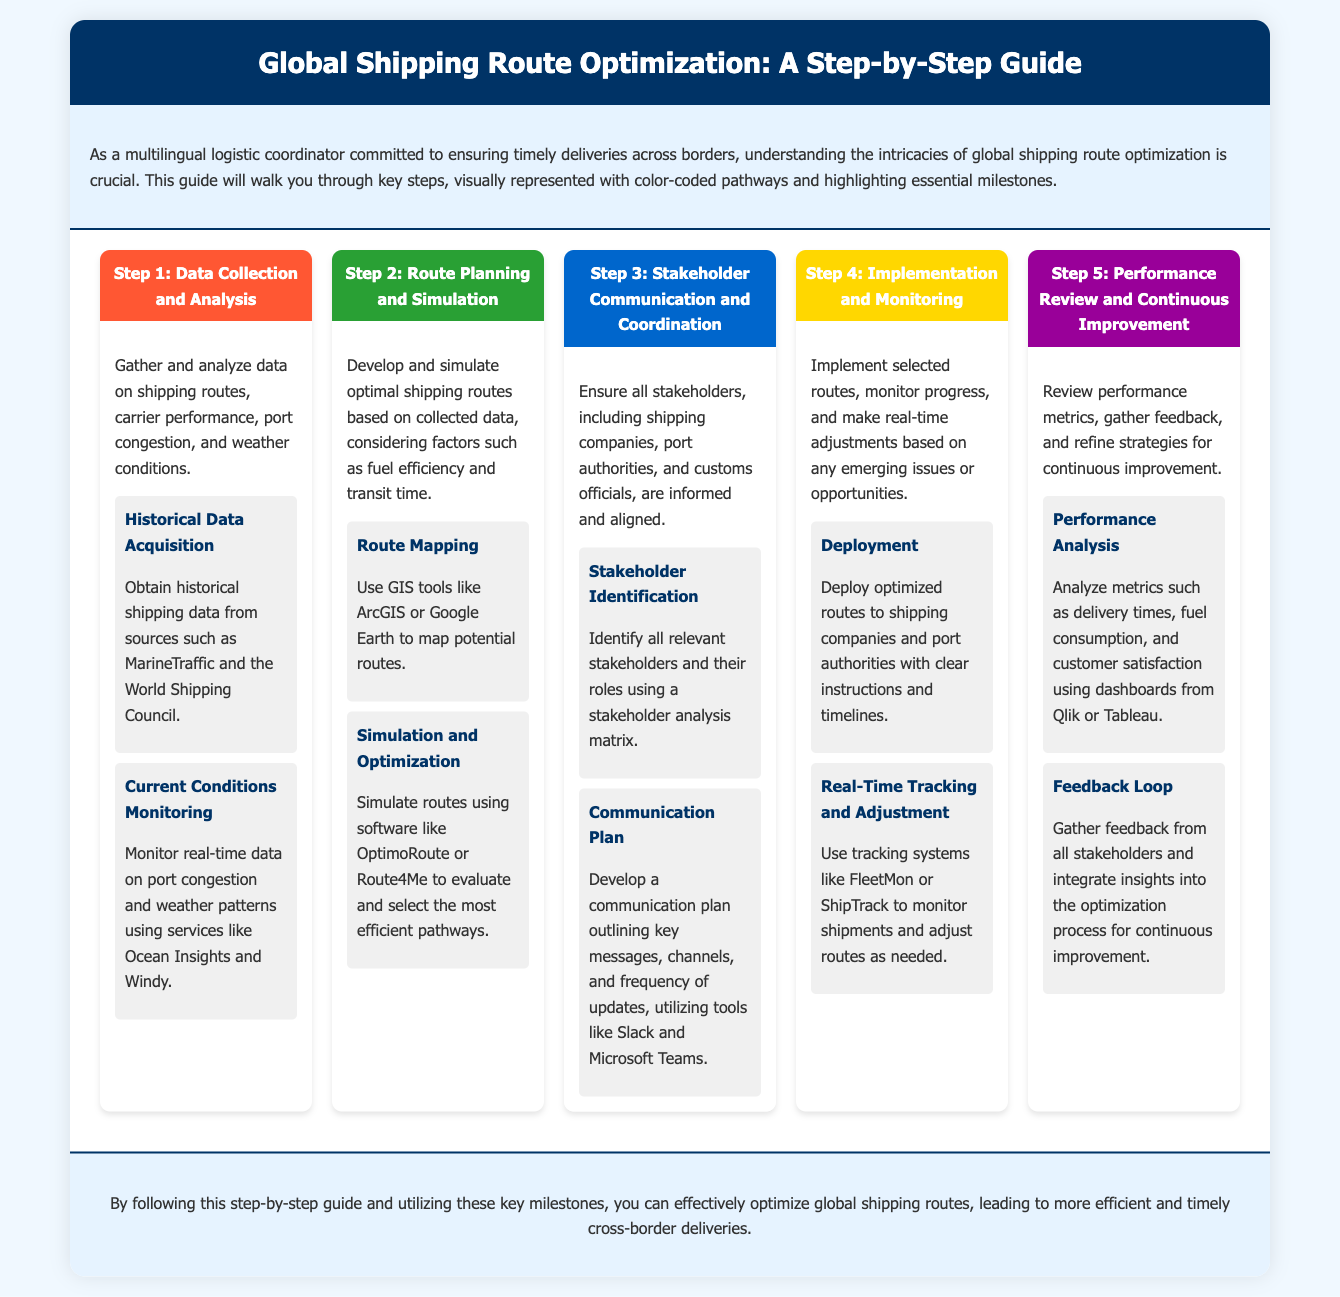What is the title of the guide? The title of the guide is prominently displayed in the header section of the document.
Answer: Global Shipping Route Optimization: A Step-by-Step Guide How many steps are in the process? The number of steps is indicated by the headings for each step listed in the infographic.
Answer: 5 What color represents Step 3? The color representing Step 3 is specified in the step header's styling within the infographic.
Answer: Blue What is one tool mentioned for Route Mapping? The document lists tools that can be used for specific tasks; the answer is found within Step 2's milestones.
Answer: ArcGIS What metric is analyzed in the Performance Review step? The specific performance metrics are outlined in Step 5's milestones and detail areas of focus.
Answer: Delivery times What is the purpose of the communication plan mentioned in Step 3? The purpose can be inferred from the content of Step 3 related to keeping stakeholders informed and aligned.
Answer: To ensure all stakeholders are informed and aligned What is a key milestone in Step 1? Key milestones are explicitly listed with headings under each step, making it easy to spot significant actions.
Answer: Historical Data Acquisition Which software is suggested for simulation in Step 2? This information is directly stated in the milestones section of Step 2, listing specific software options.
Answer: OptimoRoute 